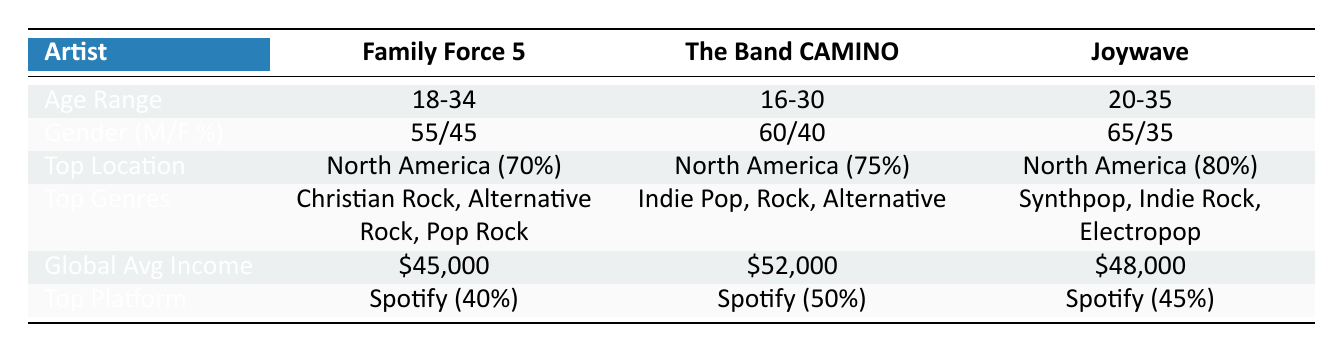What is the age range of Family Force 5? The table clearly indicates that the age range for Family Force 5 is listed under the "Age Range" row. Hence, it can be directly retrieved.
Answer: 18-34 Which artist has the highest male percentage in their audience? By looking at the gender distribution percentages for each artist, Family Force 5 has 55% male, The Band CAMINO has 60%, and Joywave has 65%. Joywave has the highest male percentage at 65%.
Answer: Joywave What percentage of The Band CAMINO's audience is located in North America? The table specifies that North America accounts for 75% of The Band CAMINO’s audience. This data can be found directly in the "Top Location" row for that artist.
Answer: 75% What is the global average income of Family Force 5 compared to Joywave? The global average income for Family Force 5 is $45,000, while Joywave's is $48,000. The difference can be calculated as $48,000 - $45,000 = $3,000.
Answer: $3,000 Is it true that all artists have their largest audience demographic in North America? The table shows that for all three artists—Family Force 5, The Band CAMINO, and Joywave—North America is the top location, with percentages of 70%, 75%, and 80%, respectively. Therefore, the statement is true.
Answer: Yes What are the top genres for The Band CAMINO? The top genres are explicitly listed in the table corresponding to The Band CAMINO, and they include Indie Pop, Rock, and Alternative.
Answer: Indie Pop, Rock, Alternative If we average the male audience percentages of all three artists, what is the result? To find the average male percentage, sum up the male percentages: 55 + 60 + 65 = 180, and then divide by 3, giving us an average of 180/3 = 60%.
Answer: 60% Which artist has the lowest income in Asia? The average income for Asia is provided for all three artists. Family Force 5 has $30,000, The Band CAMINO has $40,000, and Joywave has $33,000. The lowest income in Asia belongs to Family Force 5.
Answer: Family Force 5 What listening platform has the highest percentage for Joywave? The statistics for listening platforms show that Spotify is the most utilized service among Joywave's audience, accounting for 45%. This is evident in the “Top Platform” row specifically for Joywave.
Answer: Spotify 